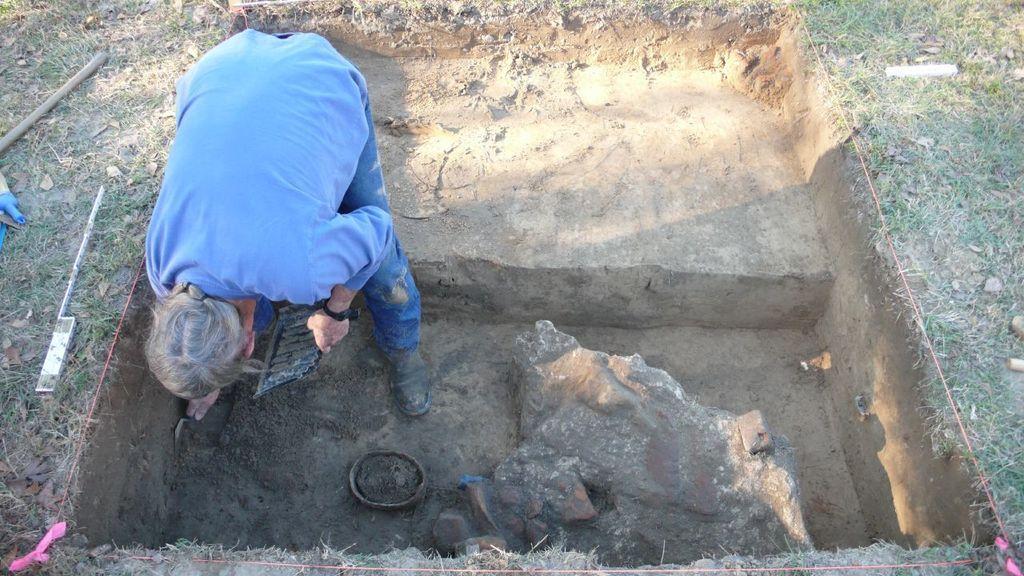Describe this image in one or two sentences. In this image we can see a person standing on the ground holding a tool and a tray. We can also see some grass, tools, a stick, a bowl of mud, the rock and a thread around him. 